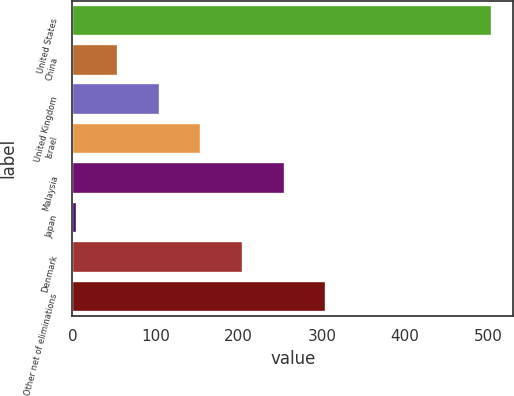Convert chart. <chart><loc_0><loc_0><loc_500><loc_500><bar_chart><fcel>United States<fcel>China<fcel>United Kingdom<fcel>Israel<fcel>Malaysia<fcel>Japan<fcel>Denmark<fcel>Other net of eliminations<nl><fcel>505<fcel>55<fcel>105<fcel>155<fcel>255<fcel>5<fcel>205<fcel>305<nl></chart> 